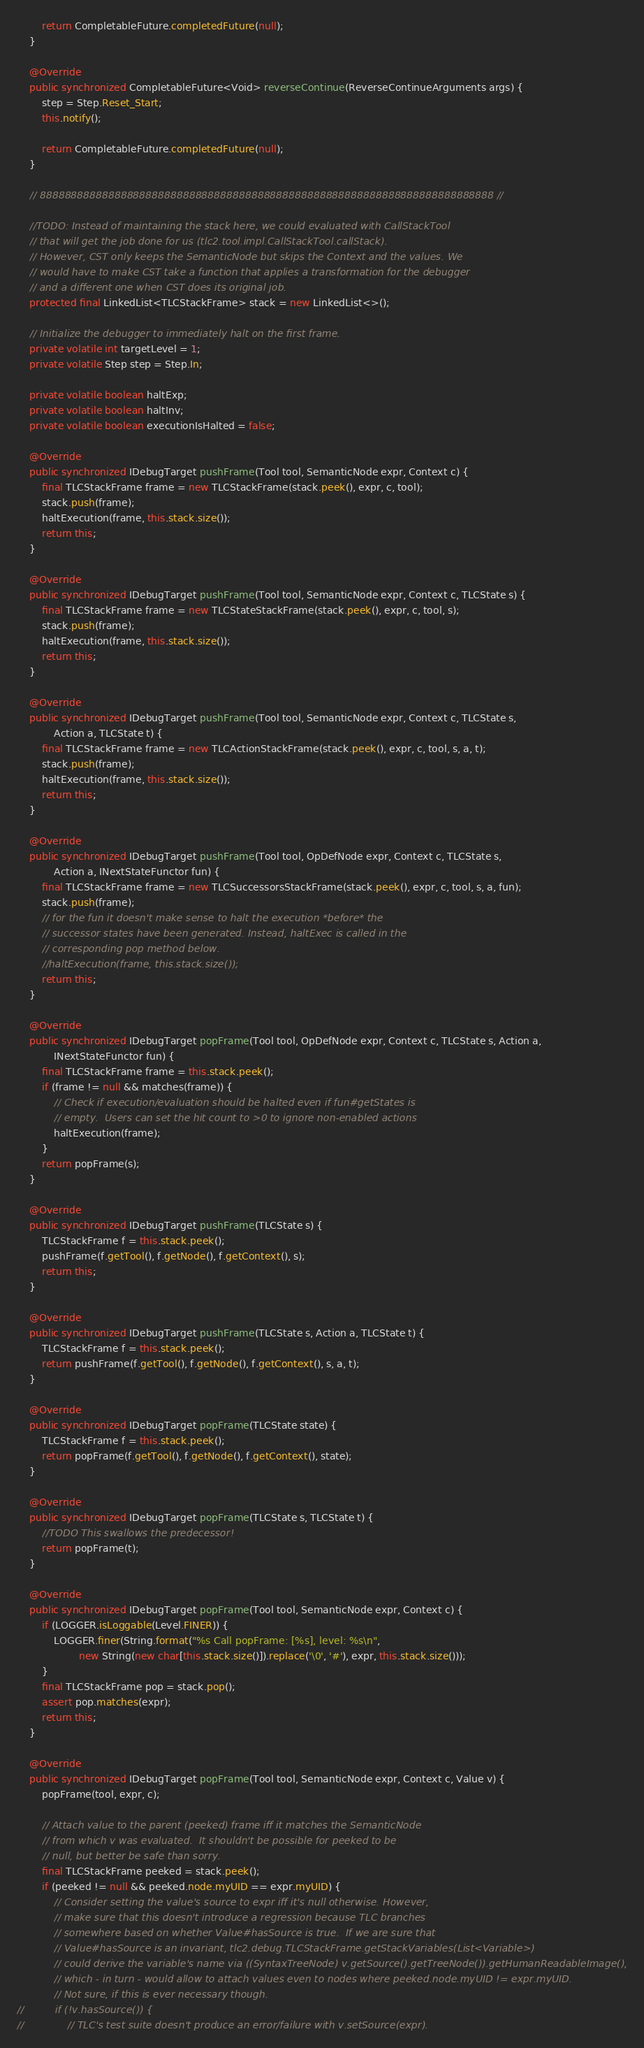<code> <loc_0><loc_0><loc_500><loc_500><_Java_>		return CompletableFuture.completedFuture(null);
	}

	@Override
	public synchronized CompletableFuture<Void> reverseContinue(ReverseContinueArguments args) {
		step = Step.Reset_Start;
		this.notify();

		return CompletableFuture.completedFuture(null);
	}

	// 8888888888888888888888888888888888888888888888888888888888888888888888888 //

	//TODO: Instead of maintaining the stack here, we could evaluated with CallStackTool
	// that will get the job done for us (tlc2.tool.impl.CallStackTool.callStack).
	// However, CST only keeps the SemanticNode but skips the Context and the values. We
	// would have to make CST take a function that applies a transformation for the debugger
	// and a different one when CST does its original job.
	protected final LinkedList<TLCStackFrame> stack = new LinkedList<>();
	
	// Initialize the debugger to immediately halt on the first frame.
	private volatile int targetLevel = 1;
	private volatile Step step = Step.In;
	
	private volatile boolean haltExp;
	private volatile boolean haltInv;
	private volatile boolean executionIsHalted = false;
	
	@Override
	public synchronized IDebugTarget pushFrame(Tool tool, SemanticNode expr, Context c) {
		final TLCStackFrame frame = new TLCStackFrame(stack.peek(), expr, c, tool);
		stack.push(frame);
		haltExecution(frame, this.stack.size());
		return this;
	}

	@Override
	public synchronized IDebugTarget pushFrame(Tool tool, SemanticNode expr, Context c, TLCState s) {
		final TLCStackFrame frame = new TLCStateStackFrame(stack.peek(), expr, c, tool, s);
		stack.push(frame);
		haltExecution(frame, this.stack.size());
		return this;
	}

	@Override
	public synchronized IDebugTarget pushFrame(Tool tool, SemanticNode expr, Context c, TLCState s,
			Action a, TLCState t) {
		final TLCStackFrame frame = new TLCActionStackFrame(stack.peek(), expr, c, tool, s, a, t);
		stack.push(frame);
		haltExecution(frame, this.stack.size());
		return this;
	}

	@Override
	public synchronized IDebugTarget pushFrame(Tool tool, OpDefNode expr, Context c, TLCState s,
			Action a, INextStateFunctor fun) {
		final TLCStackFrame frame = new TLCSuccessorsStackFrame(stack.peek(), expr, c, tool, s, a, fun);
		stack.push(frame);
		// for the fun it doesn't make sense to halt the execution *before* the
		// successor states have been generated. Instead, haltExec is called in the
		// corresponding pop method below.
		//haltExecution(frame, this.stack.size());
		return this;
	}

	@Override
	public synchronized IDebugTarget popFrame(Tool tool, OpDefNode expr, Context c, TLCState s, Action a,
			INextStateFunctor fun) {
		final TLCStackFrame frame = this.stack.peek();
		if (frame != null && matches(frame)) {
			// Check if execution/evaluation should be halted even if fun#getStates is
			// empty.  Users can set the hit count to >0 to ignore non-enabled actions
			haltExecution(frame);
		}
		return popFrame(s);
	}

	@Override
	public synchronized IDebugTarget pushFrame(TLCState s) {
		TLCStackFrame f = this.stack.peek();
		pushFrame(f.getTool(), f.getNode(), f.getContext(), s);
		return this;
	}

	@Override
	public synchronized IDebugTarget pushFrame(TLCState s, Action a, TLCState t) {
		TLCStackFrame f = this.stack.peek();
		return pushFrame(f.getTool(), f.getNode(), f.getContext(), s, a, t);
	}

	@Override
	public synchronized IDebugTarget popFrame(TLCState state) {
		TLCStackFrame f = this.stack.peek();
		return popFrame(f.getTool(), f.getNode(), f.getContext(), state);
	}

	@Override
	public synchronized IDebugTarget popFrame(TLCState s, TLCState t) {
		//TODO This swallows the predecessor!
		return popFrame(t);
	}

	@Override
	public synchronized IDebugTarget popFrame(Tool tool, SemanticNode expr, Context c) {
		if (LOGGER.isLoggable(Level.FINER)) {
			LOGGER.finer(String.format("%s Call popFrame: [%s], level: %s\n",
					new String(new char[this.stack.size()]).replace('\0', '#'), expr, this.stack.size()));
		}
		final TLCStackFrame pop = stack.pop();
		assert pop.matches(expr);
		return this;
	}

	@Override
	public synchronized IDebugTarget popFrame(Tool tool, SemanticNode expr, Context c, Value v) {
		popFrame(tool, expr, c);

		// Attach value to the parent (peeked) frame iff it matches the SemanticNode
		// from which v was evaluated.  It shouldn't be possible for peeked to be
		// null, but better be safe than sorry.
		final TLCStackFrame peeked = stack.peek();
		if (peeked != null && peeked.node.myUID == expr.myUID) {
			// Consider setting the value's source to expr iff it's null otherwise. However,
			// make sure that this doesn't introduce a regression because TLC branches
			// somewhere based on whether Value#hasSource is true.  If we are sure that
			// Value#hasSource is an invariant, tlc2.debug.TLCStackFrame.getStackVariables(List<Variable>)
			// could derive the variable's name via ((SyntaxTreeNode) v.getSource().getTreeNode()).getHumanReadableImage(),
			// which - in turn - would allow to attach values even to nodes where peeked.node.myUID != expr.myUID.
			// Not sure, if this is ever necessary though.
//			if (!v.hasSource()) {
//				// TLC's test suite doesn't produce an error/failure with v.setSource(expr).</code> 